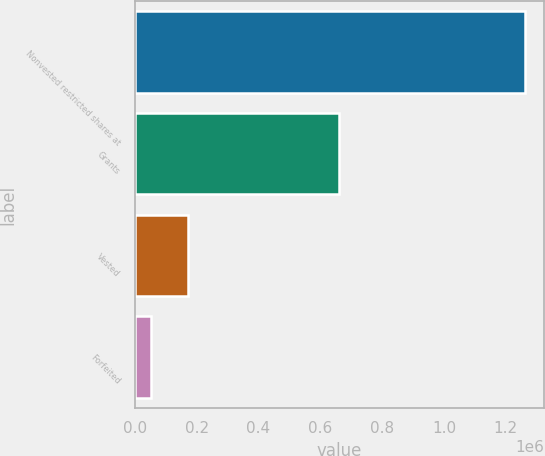Convert chart. <chart><loc_0><loc_0><loc_500><loc_500><bar_chart><fcel>Nonvested restricted shares at<fcel>Grants<fcel>Vested<fcel>Forfeited<nl><fcel>1.26177e+06<fcel>661792<fcel>172329<fcel>51280<nl></chart> 